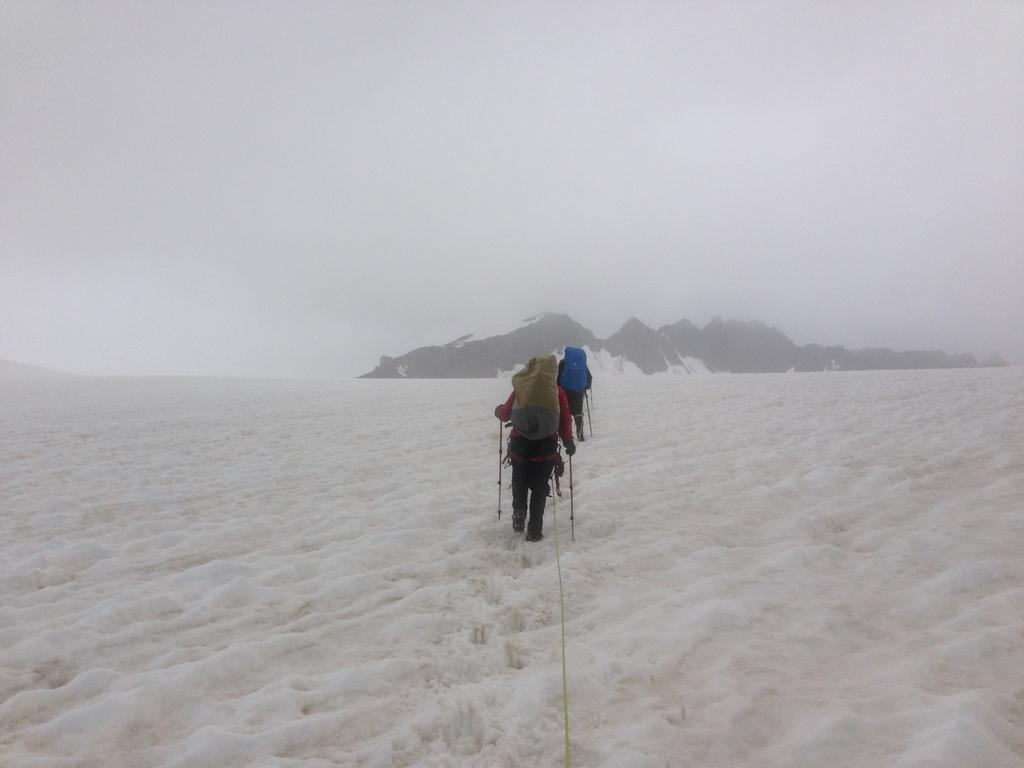How many people are in the image? There are two persons in the image. What are the persons doing in the image? The persons are walking. What are the persons carrying on their backs? The persons are wearing bags. What is the ground covered with in the image? There is snow at the bottom of the image. What can be seen in the distance in the image? There are mountains in the background of the image. What type of event is happening in the image? There is no specific event happening in the image; it simply shows two people walking in a snowy environment with mountains in the background. Can you see a wrench being used by one of the persons in the image? No, there is no wrench visible in the image. 